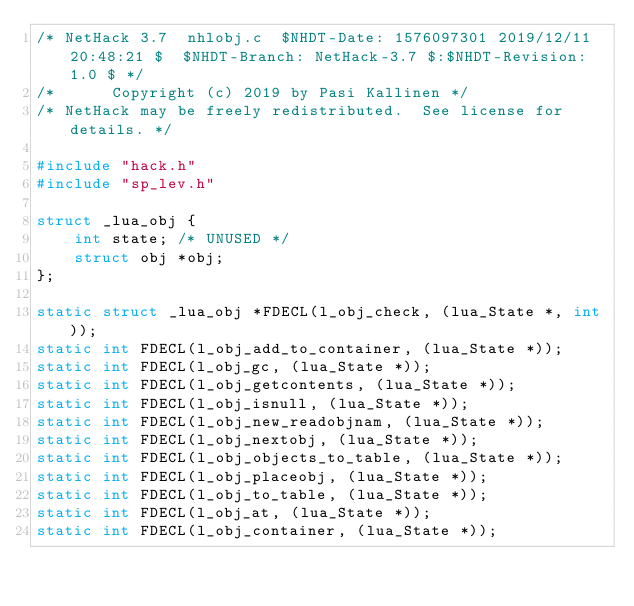Convert code to text. <code><loc_0><loc_0><loc_500><loc_500><_C_>/* NetHack 3.7	nhlobj.c	$NHDT-Date: 1576097301 2019/12/11 20:48:21 $  $NHDT-Branch: NetHack-3.7 $:$NHDT-Revision: 1.0 $ */
/*      Copyright (c) 2019 by Pasi Kallinen */
/* NetHack may be freely redistributed.  See license for details. */

#include "hack.h"
#include "sp_lev.h"

struct _lua_obj {
    int state; /* UNUSED */
    struct obj *obj;
};

static struct _lua_obj *FDECL(l_obj_check, (lua_State *, int));
static int FDECL(l_obj_add_to_container, (lua_State *));
static int FDECL(l_obj_gc, (lua_State *));
static int FDECL(l_obj_getcontents, (lua_State *));
static int FDECL(l_obj_isnull, (lua_State *));
static int FDECL(l_obj_new_readobjnam, (lua_State *));
static int FDECL(l_obj_nextobj, (lua_State *));
static int FDECL(l_obj_objects_to_table, (lua_State *));
static int FDECL(l_obj_placeobj, (lua_State *));
static int FDECL(l_obj_to_table, (lua_State *));
static int FDECL(l_obj_at, (lua_State *));
static int FDECL(l_obj_container, (lua_State *));
</code> 